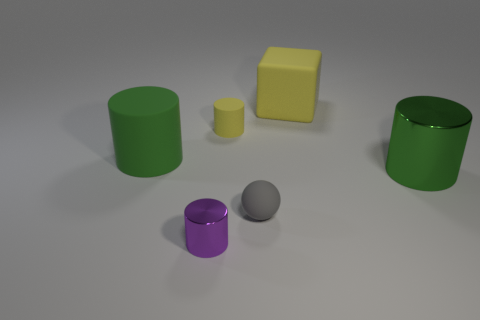How big is the green shiny thing?
Give a very brief answer. Large. What shape is the large green metal object behind the gray rubber sphere?
Your answer should be compact. Cylinder. Do the large green rubber thing and the tiny purple object have the same shape?
Make the answer very short. Yes. Are there the same number of large green matte cylinders in front of the small purple thing and tiny blue rubber things?
Provide a short and direct response. Yes. What shape is the green metal thing?
Your answer should be very brief. Cylinder. Is there any other thing that has the same color as the small metal thing?
Your answer should be compact. No. Do the shiny cylinder that is behind the gray rubber object and the green cylinder on the left side of the large metallic object have the same size?
Your answer should be compact. Yes. What is the shape of the shiny object that is right of the tiny thing behind the green shiny object?
Offer a terse response. Cylinder. There is a gray matte object; is its size the same as the green cylinder to the right of the large yellow rubber block?
Make the answer very short. No. What size is the green object to the right of the large cylinder left of the cylinder to the right of the tiny gray ball?
Make the answer very short. Large. 